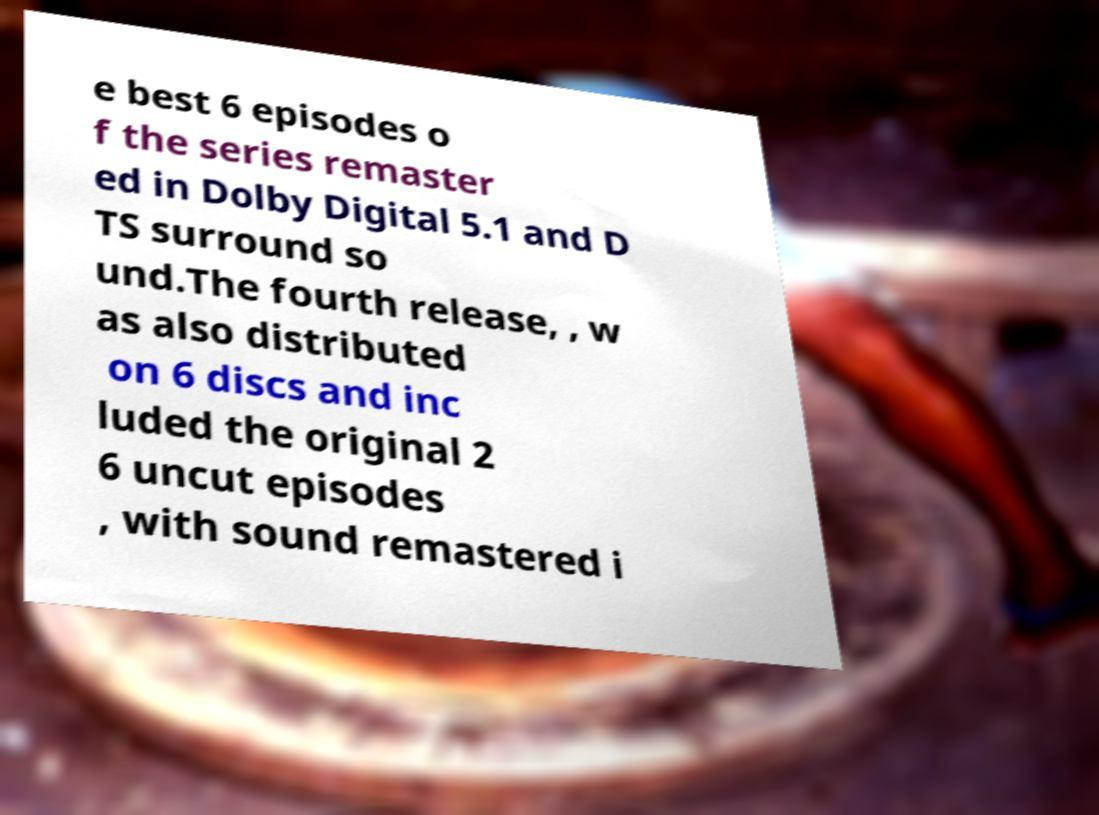I need the written content from this picture converted into text. Can you do that? e best 6 episodes o f the series remaster ed in Dolby Digital 5.1 and D TS surround so und.The fourth release, , w as also distributed on 6 discs and inc luded the original 2 6 uncut episodes , with sound remastered i 